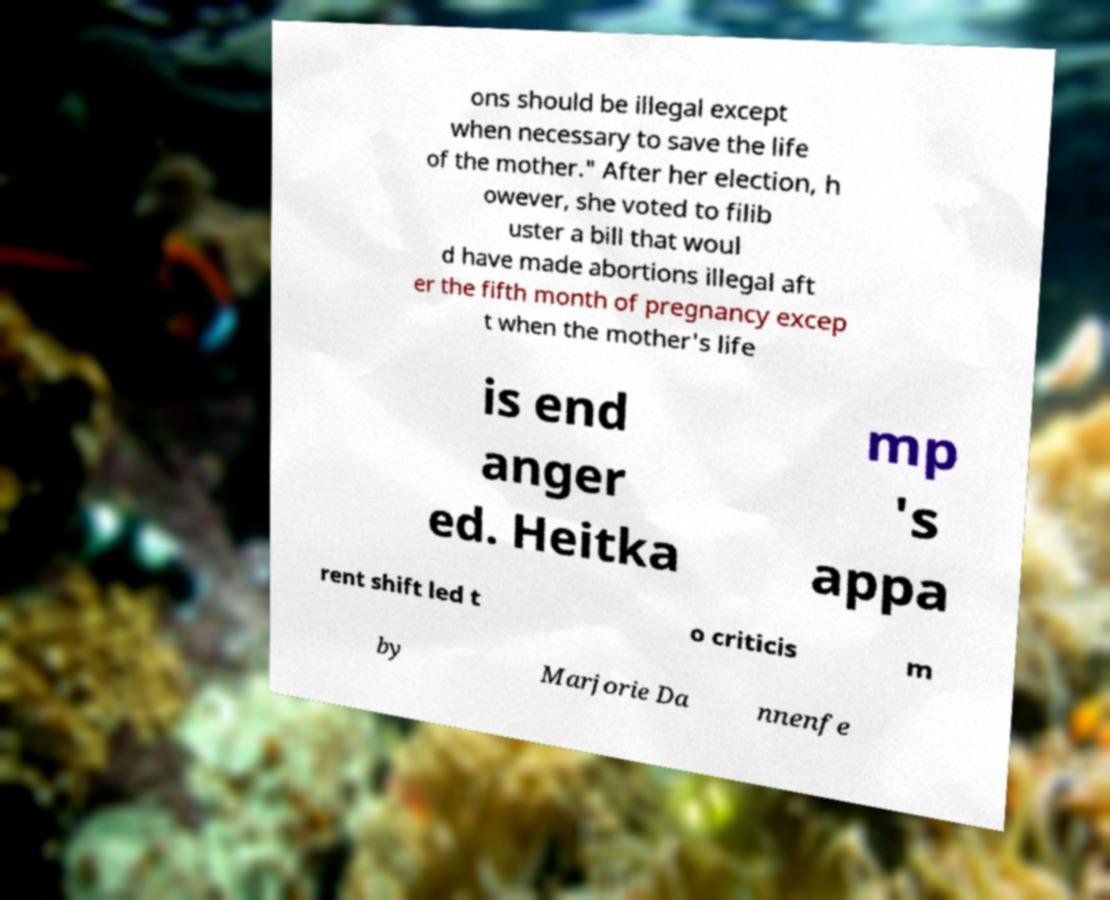For documentation purposes, I need the text within this image transcribed. Could you provide that? ons should be illegal except when necessary to save the life of the mother." After her election, h owever, she voted to filib uster a bill that woul d have made abortions illegal aft er the fifth month of pregnancy excep t when the mother's life is end anger ed. Heitka mp 's appa rent shift led t o criticis m by Marjorie Da nnenfe 